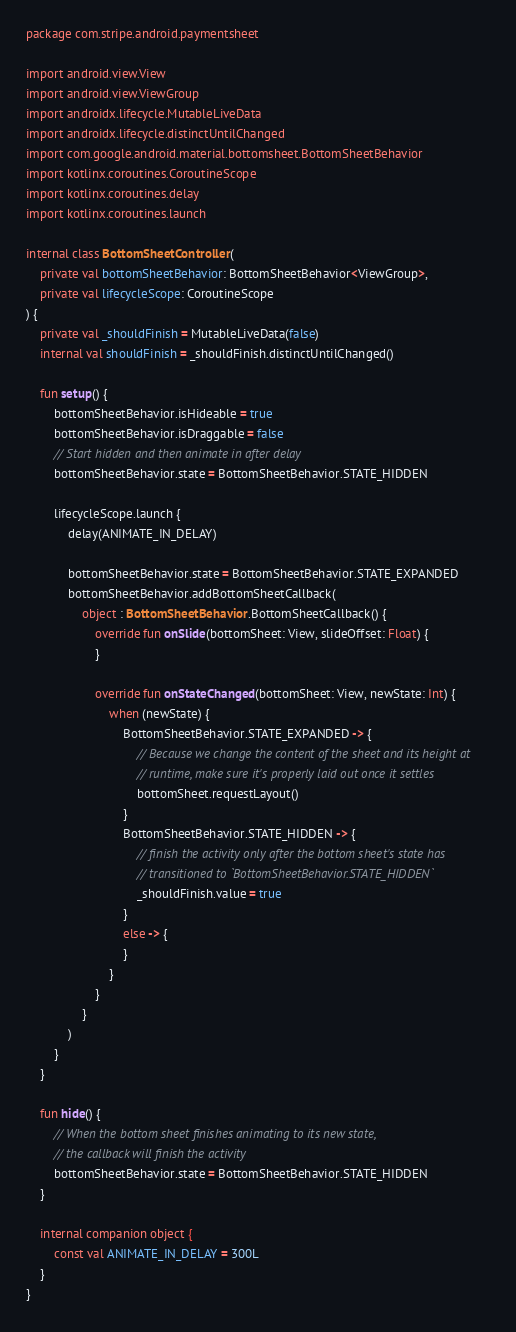Convert code to text. <code><loc_0><loc_0><loc_500><loc_500><_Kotlin_>package com.stripe.android.paymentsheet

import android.view.View
import android.view.ViewGroup
import androidx.lifecycle.MutableLiveData
import androidx.lifecycle.distinctUntilChanged
import com.google.android.material.bottomsheet.BottomSheetBehavior
import kotlinx.coroutines.CoroutineScope
import kotlinx.coroutines.delay
import kotlinx.coroutines.launch

internal class BottomSheetController(
    private val bottomSheetBehavior: BottomSheetBehavior<ViewGroup>,
    private val lifecycleScope: CoroutineScope
) {
    private val _shouldFinish = MutableLiveData(false)
    internal val shouldFinish = _shouldFinish.distinctUntilChanged()

    fun setup() {
        bottomSheetBehavior.isHideable = true
        bottomSheetBehavior.isDraggable = false
        // Start hidden and then animate in after delay
        bottomSheetBehavior.state = BottomSheetBehavior.STATE_HIDDEN

        lifecycleScope.launch {
            delay(ANIMATE_IN_DELAY)

            bottomSheetBehavior.state = BottomSheetBehavior.STATE_EXPANDED
            bottomSheetBehavior.addBottomSheetCallback(
                object : BottomSheetBehavior.BottomSheetCallback() {
                    override fun onSlide(bottomSheet: View, slideOffset: Float) {
                    }

                    override fun onStateChanged(bottomSheet: View, newState: Int) {
                        when (newState) {
                            BottomSheetBehavior.STATE_EXPANDED -> {
                                // Because we change the content of the sheet and its height at
                                // runtime, make sure it's properly laid out once it settles
                                bottomSheet.requestLayout()
                            }
                            BottomSheetBehavior.STATE_HIDDEN -> {
                                // finish the activity only after the bottom sheet's state has
                                // transitioned to `BottomSheetBehavior.STATE_HIDDEN`
                                _shouldFinish.value = true
                            }
                            else -> {
                            }
                        }
                    }
                }
            )
        }
    }

    fun hide() {
        // When the bottom sheet finishes animating to its new state,
        // the callback will finish the activity
        bottomSheetBehavior.state = BottomSheetBehavior.STATE_HIDDEN
    }

    internal companion object {
        const val ANIMATE_IN_DELAY = 300L
    }
}
</code> 